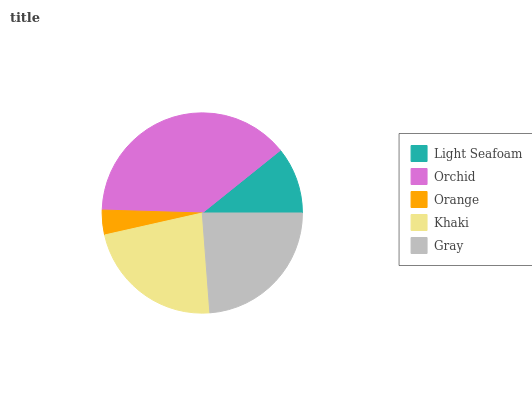Is Orange the minimum?
Answer yes or no. Yes. Is Orchid the maximum?
Answer yes or no. Yes. Is Orchid the minimum?
Answer yes or no. No. Is Orange the maximum?
Answer yes or no. No. Is Orchid greater than Orange?
Answer yes or no. Yes. Is Orange less than Orchid?
Answer yes or no. Yes. Is Orange greater than Orchid?
Answer yes or no. No. Is Orchid less than Orange?
Answer yes or no. No. Is Khaki the high median?
Answer yes or no. Yes. Is Khaki the low median?
Answer yes or no. Yes. Is Gray the high median?
Answer yes or no. No. Is Light Seafoam the low median?
Answer yes or no. No. 